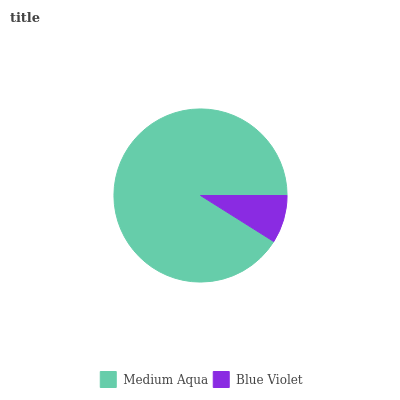Is Blue Violet the minimum?
Answer yes or no. Yes. Is Medium Aqua the maximum?
Answer yes or no. Yes. Is Blue Violet the maximum?
Answer yes or no. No. Is Medium Aqua greater than Blue Violet?
Answer yes or no. Yes. Is Blue Violet less than Medium Aqua?
Answer yes or no. Yes. Is Blue Violet greater than Medium Aqua?
Answer yes or no. No. Is Medium Aqua less than Blue Violet?
Answer yes or no. No. Is Medium Aqua the high median?
Answer yes or no. Yes. Is Blue Violet the low median?
Answer yes or no. Yes. Is Blue Violet the high median?
Answer yes or no. No. Is Medium Aqua the low median?
Answer yes or no. No. 